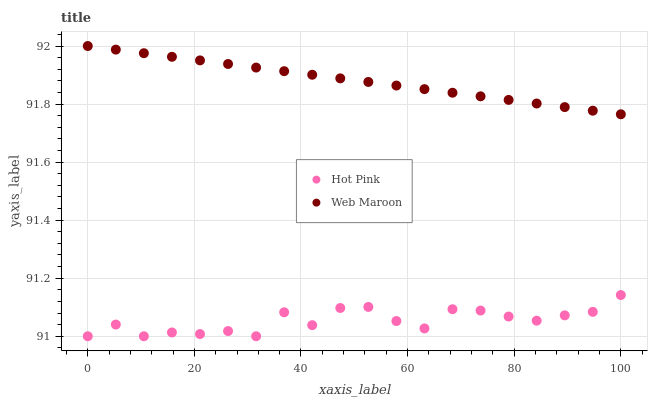Does Hot Pink have the minimum area under the curve?
Answer yes or no. Yes. Does Web Maroon have the maximum area under the curve?
Answer yes or no. Yes. Does Web Maroon have the minimum area under the curve?
Answer yes or no. No. Is Web Maroon the smoothest?
Answer yes or no. Yes. Is Hot Pink the roughest?
Answer yes or no. Yes. Is Web Maroon the roughest?
Answer yes or no. No. Does Hot Pink have the lowest value?
Answer yes or no. Yes. Does Web Maroon have the lowest value?
Answer yes or no. No. Does Web Maroon have the highest value?
Answer yes or no. Yes. Is Hot Pink less than Web Maroon?
Answer yes or no. Yes. Is Web Maroon greater than Hot Pink?
Answer yes or no. Yes. Does Hot Pink intersect Web Maroon?
Answer yes or no. No. 